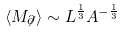Convert formula to latex. <formula><loc_0><loc_0><loc_500><loc_500>\left < M _ { \not \partial } \right > \sim L ^ { \frac { 1 } { 3 } } A ^ { - \frac { 1 } { 3 } }</formula> 